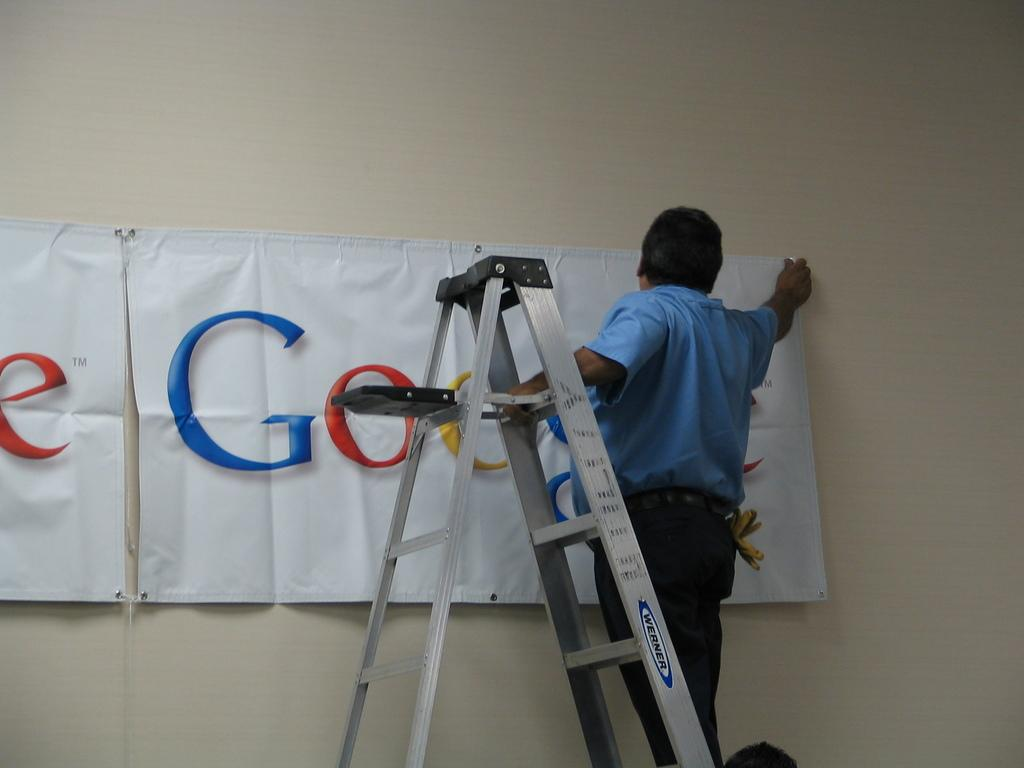Who is the main subject in the image? There is a man in the image. What is the man doing in the image? The man is standing on a ladder and pasting a banner on a wall. What is written on the banner? The banner has the word "Google" written on it. What time of day is it in the image? The time of day is not mentioned in the image, so it cannot be determined from the image alone. 